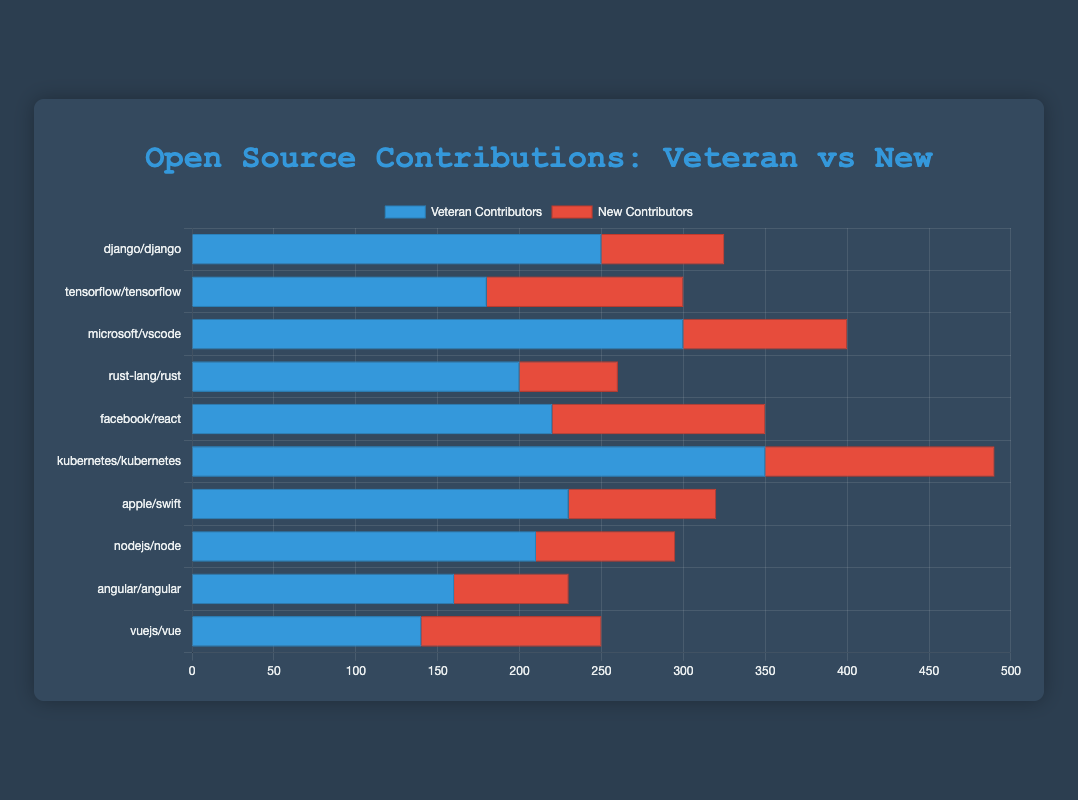Which repository has the highest number of veteran contributors? By examining the horizontal bars for veteran contributors (represented in blue), we can see that "kubernetes/kubernetes" has the longest bar. Therefore, it has the highest number of veteran contributors.
Answer: kubernetes/kubernetes Which repository has more new contributors, "tensorflow/tensorflow" or "facebook/react"? Comparing the lengths of the red bars for new contributors between "tensorflow/tensorflow" and "facebook/react," we observe that "facebook/react" has a longer red bar, indicating more new contributors.
Answer: facebook/react What is the total number of contributors for the "rust-lang/rust" repository? Summing the contributions for "rust-lang/rust": veteran contributors (200) + new contributors (60) = 260 total contributors.
Answer: 260 Which repository has the smallest number of total contributors, and what is that number? By adding up veteran and new contributors for each repository and comparing the totals, "vuejs/vue" has the fewest with 140 veteran and 110 new contributors, totaling 250 contributors.
Answer: vuejs/vue, 250 How many more veteran contributors does "microsoft/vscode" have compared to "apple/swift"? Subtracting the number of veteran contributors: "microsoft/vscode" (300) - "apple/swift" (230) = 70 more veteran contributors.
Answer: 70 Which repository shows the most balanced ratio between veteran and new contributors? By examining the lengths of the blue and red bars, "vuejs/vue" seems the most balanced since the lengths of the bars for veteran (140) and new (110) contributors are relatively close.
Answer: vuejs/vue What's the average number of new contributors across all repositories? Summing the number of new contributors for each repository (75+120+100+60+130+140+90+85+70+110 = 980) and dividing by the number of repositories (10), the average is 980/10 = 98.
Answer: 98 What is the difference between the repository with the most veteran contributors and the one with the fewest veteran contributors? The repository with the most veteran contributors is "kubernetes/kubernetes" (350), and the one with the fewest is "vuejs/vue" (140). The difference is 350 - 140 = 210.
Answer: 210 Which repository has the highest combined total of veteran and new contributors, and what is that total? The "kubernetes/kubernetes" repository has the longest combined length of blue and red bars, giving it the highest total. Summing its veteran (350) and new contributors (140) gives a total of 490.
Answer: kubernetes/kubernetes, 490 